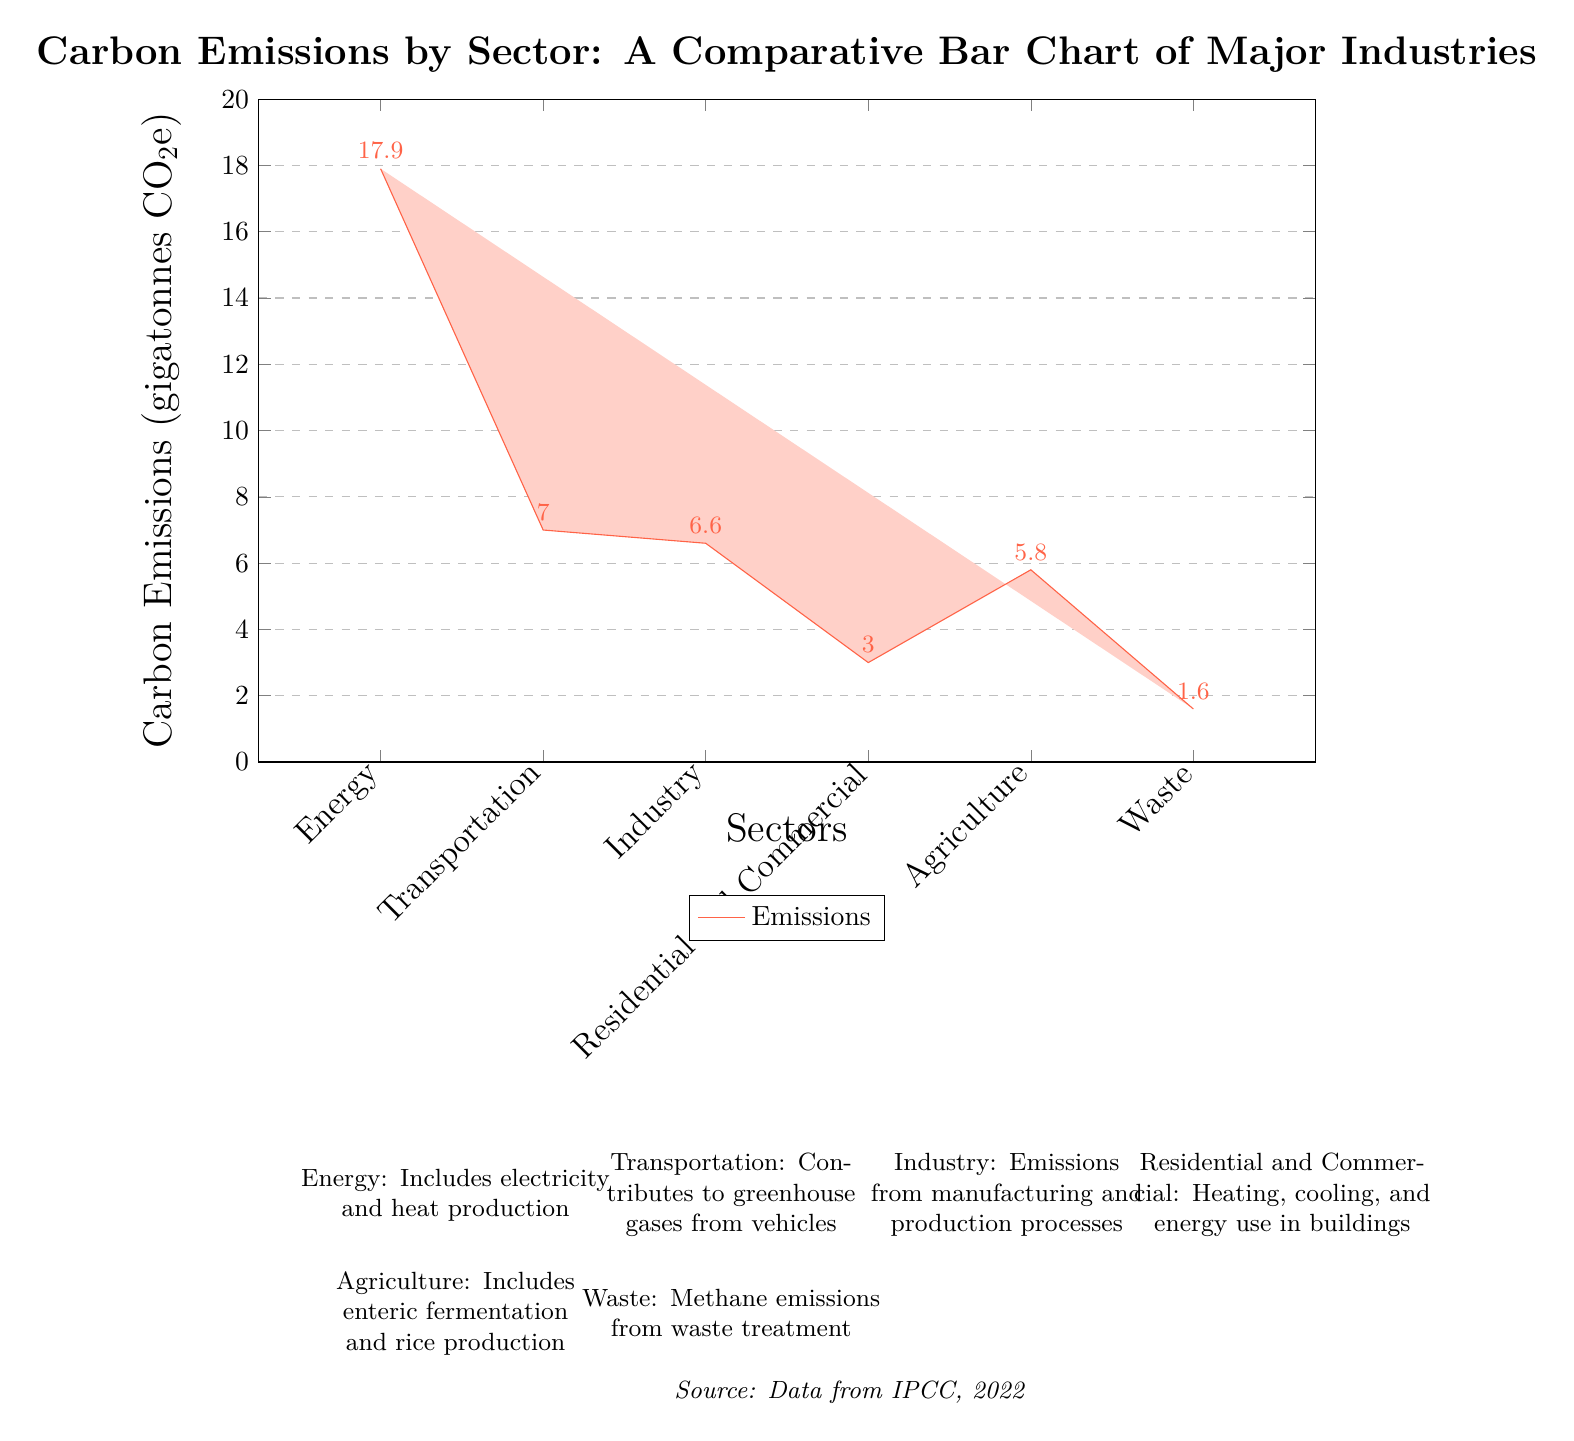What is the highest carbon emissions sector? The bar chart shows the height of each sector's emissions. The "Energy" sector has the tallest bar, indicating it has the highest emissions level compared to others.
Answer: Energy What is the carbon emissions value for Transportation? The Transportation sector's associated bar represents a specific height corresponding to its emissions value. Upon checking, the value is 7.0 gigatonnes CO2e.
Answer: 7.0 Which sector has the lowest emissions? By comparing the heights of all the bars, the "Waste" sector has the shortest bar, indicating the lowest emissions during the specified period.
Answer: Waste What is the difference in carbon emissions between Industry and Agriculture? To identify the difference, the emissions value for Industry (6.6 gigatonnes CO2e) is subtracted from Agriculture (5.8 gigatonnes CO2e). This calculation results in an emissions difference of 0.8 gigatonnes CO2e, with Industry having higher emissions.
Answer: 0.8 Which sectors have emissions below 5 gigatonnes CO2e? By observing the bars, we can identify which sectors have their respective emissions values displayed below 5 gigatonnes CO2e. The sectors that fit these criteria are "Residential and Commercial" (3.0) and "Waste" (1.6).
Answer: Residential and Commercial, Waste What is the total carbon emissions from the Agriculture and Waste sectors? To find the total, the emissions value from Agriculture (5.8 gigatonnes CO2e) is added to that from Waste (1.6 gigatonnes CO2e). This calculation gives a total of 7.4 gigatonnes CO2e combined for both sectors.
Answer: 7.4 What percentage of total emissions does the Energy sector contribute? First, the sum of all sectors' emissions is calculated, which totals 41.9 gigatonnes CO2e. The Energy sector's emissions are 17.9 gigatonnes CO2e. Thus, the percentage is calculated as (17.9 / 41.9) * 100, yielding approximately 42.7%.
Answer: 42.7% How many sectors are represented in the diagram? The diagram displays a total of six sectors, each with a corresponding emissions value. This is confirmed by counting the labeled sectors on the x-axis.
Answer: 6 Which sectors contribute to more than 5 gigatonnes CO2e? Upon checking the bar heights, sectors with emissions exceeding 5 gigatonnes CO2e are identified as "Energy" (17.9), "Transportation" (7.0), and "Industry" (6.6).
Answer: Energy, Transportation, Industry 